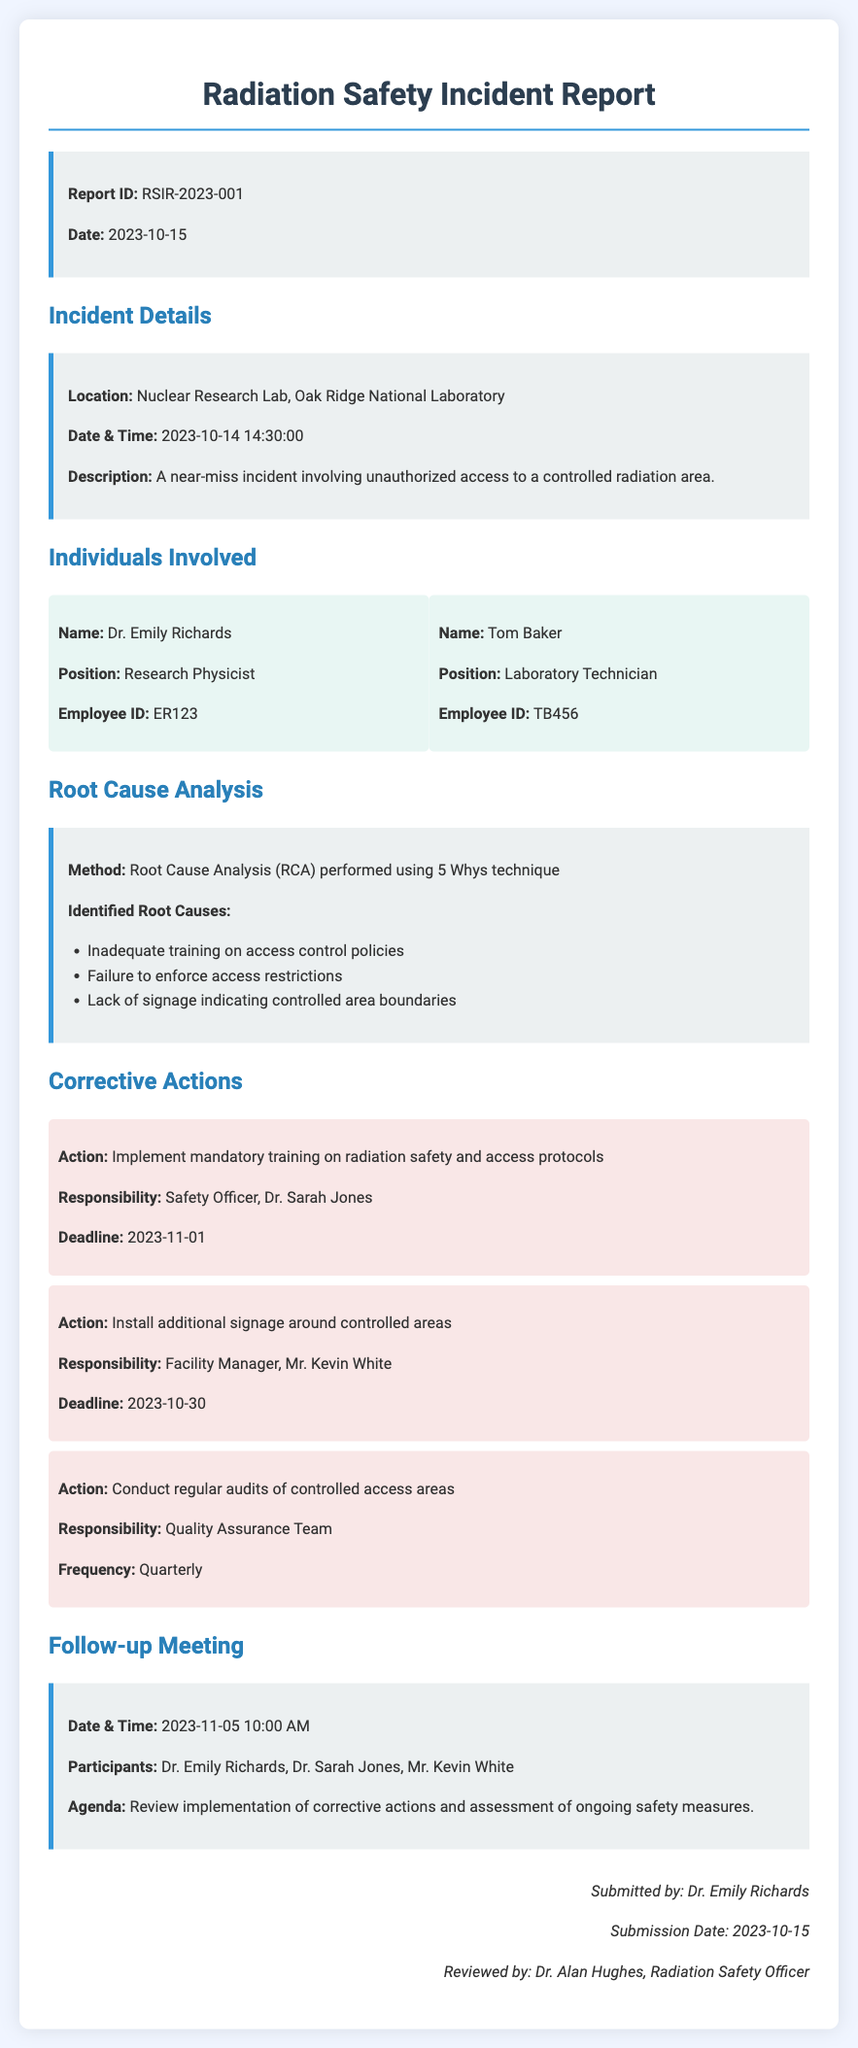What is the report ID? The report ID is a unique identifier for the incident report, found in the document's info box.
Answer: RSIR-2023-001 What date did the incident occur? The date of the incident is mentioned in the incident details section of the document.
Answer: 2023-10-14 Who is the Safety Officer responsible for corrective actions? The Safety Officer's name is indicated in the corrective actions section as responsible for training implementation.
Answer: Dr. Sarah Jones What were the identified root causes? Specific root causes are listed in bullet points under the Root Cause Analysis section.
Answer: Inadequate training on access control policies What is the deadline for installing additional signage? The deadline for the installation of signage is specified under the corrective actions section.
Answer: 2023-10-30 How often will audits of controlled access areas be conducted? The frequency of audits is mentioned in the corrective actions section.
Answer: Quarterly What is the agenda for the follow-up meeting? The agenda is a brief description of the meeting's purpose found in the follow-up meeting section.
Answer: Review implementation of corrective actions and assessment of ongoing safety measures Who reviewed the report? The name of the person who reviewed the report is listed at the bottom of the document.
Answer: Dr. Alan Hughes What is the location of the incident? The incident location is specified in the incident details section.
Answer: Nuclear Research Lab, Oak Ridge National Laboratory 